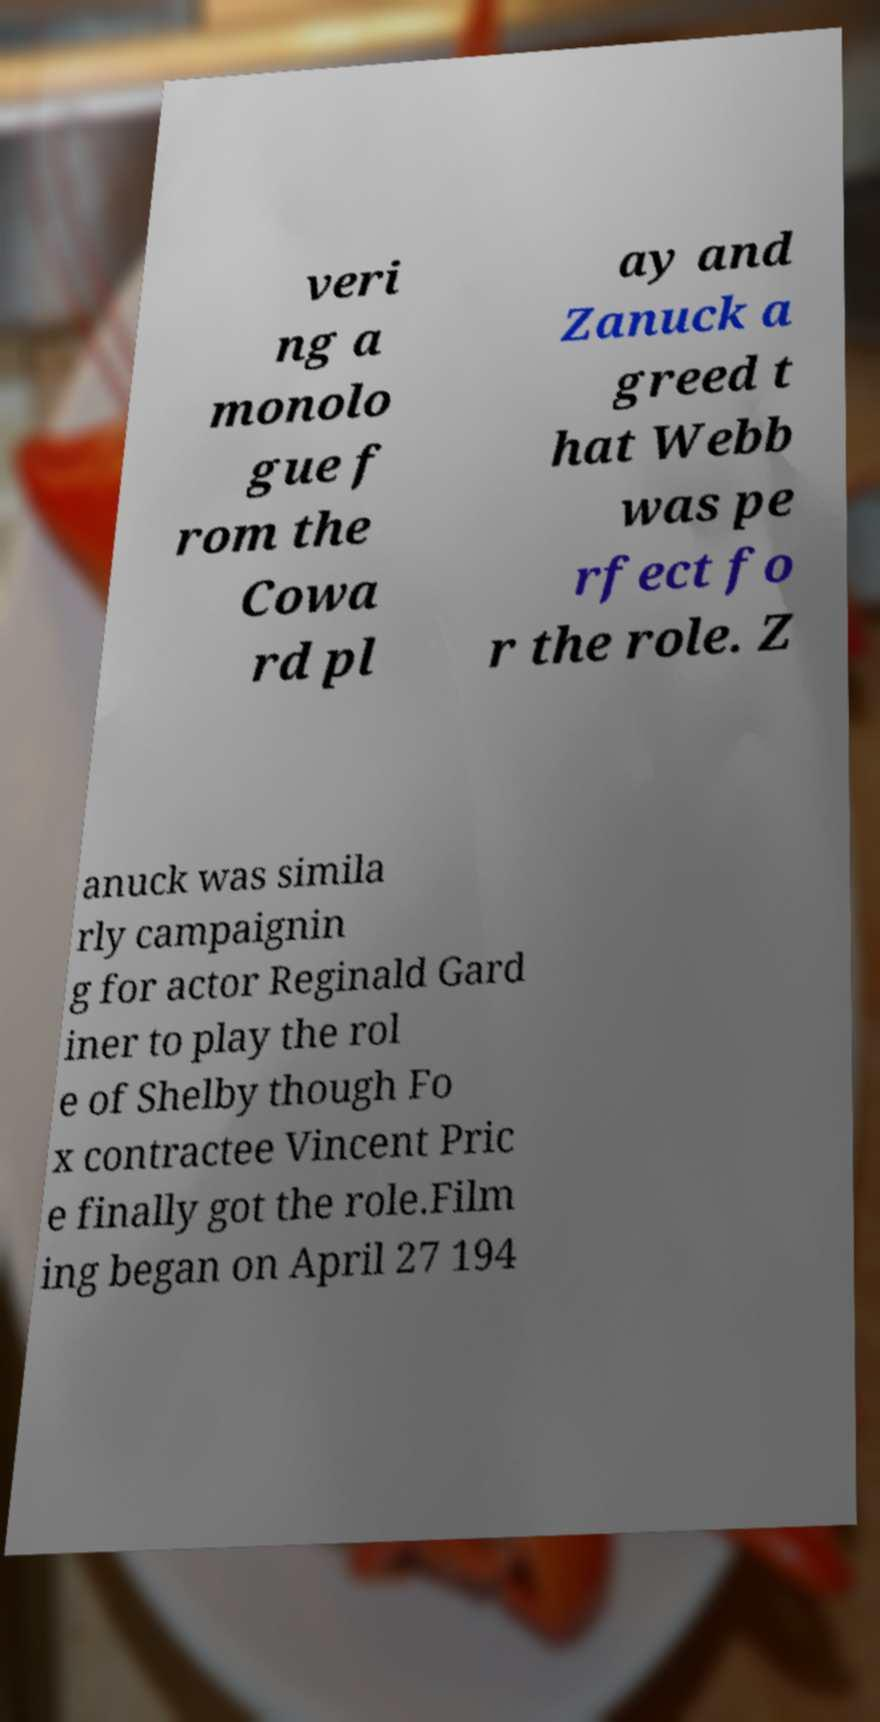For documentation purposes, I need the text within this image transcribed. Could you provide that? veri ng a monolo gue f rom the Cowa rd pl ay and Zanuck a greed t hat Webb was pe rfect fo r the role. Z anuck was simila rly campaignin g for actor Reginald Gard iner to play the rol e of Shelby though Fo x contractee Vincent Pric e finally got the role.Film ing began on April 27 194 